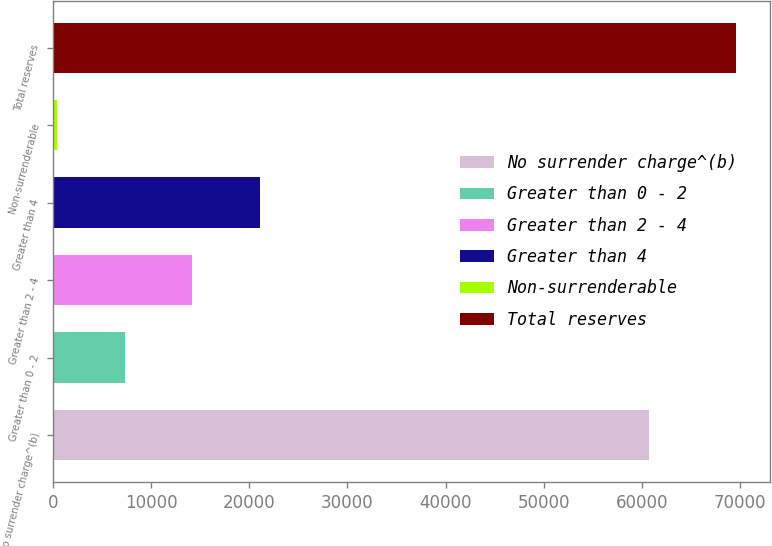Convert chart to OTSL. <chart><loc_0><loc_0><loc_500><loc_500><bar_chart><fcel>No surrender charge^(b)<fcel>Greater than 0 - 2<fcel>Greater than 2 - 4<fcel>Greater than 4<fcel>Non-surrenderable<fcel>Total reserves<nl><fcel>60743<fcel>7286.2<fcel>14212.4<fcel>21138.6<fcel>360<fcel>69622<nl></chart> 